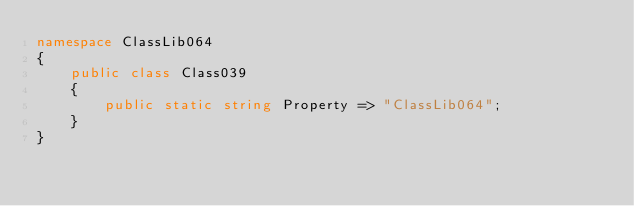<code> <loc_0><loc_0><loc_500><loc_500><_C#_>namespace ClassLib064
{
    public class Class039
    {
        public static string Property => "ClassLib064";
    }
}
</code> 